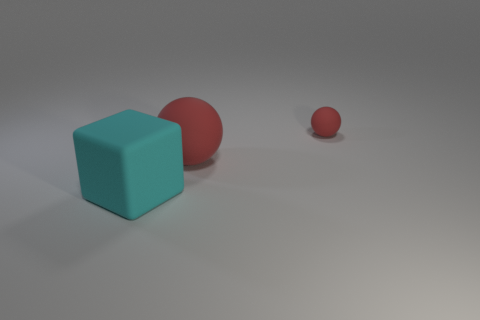Add 3 big green objects. How many objects exist? 6 Subtract all spheres. How many objects are left? 1 Subtract 0 cyan cylinders. How many objects are left? 3 Subtract all small gray rubber blocks. Subtract all tiny red spheres. How many objects are left? 2 Add 1 big red things. How many big red things are left? 2 Add 1 tiny yellow cylinders. How many tiny yellow cylinders exist? 1 